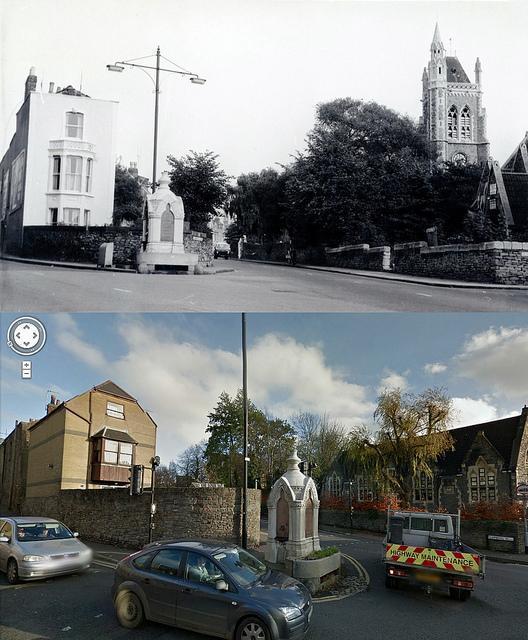How many street lights are visible?
Give a very brief answer. 2. How many frames appear in this scene?
Give a very brief answer. 2. How many red cars are there?
Give a very brief answer. 0. How many cars are there?
Give a very brief answer. 2. 